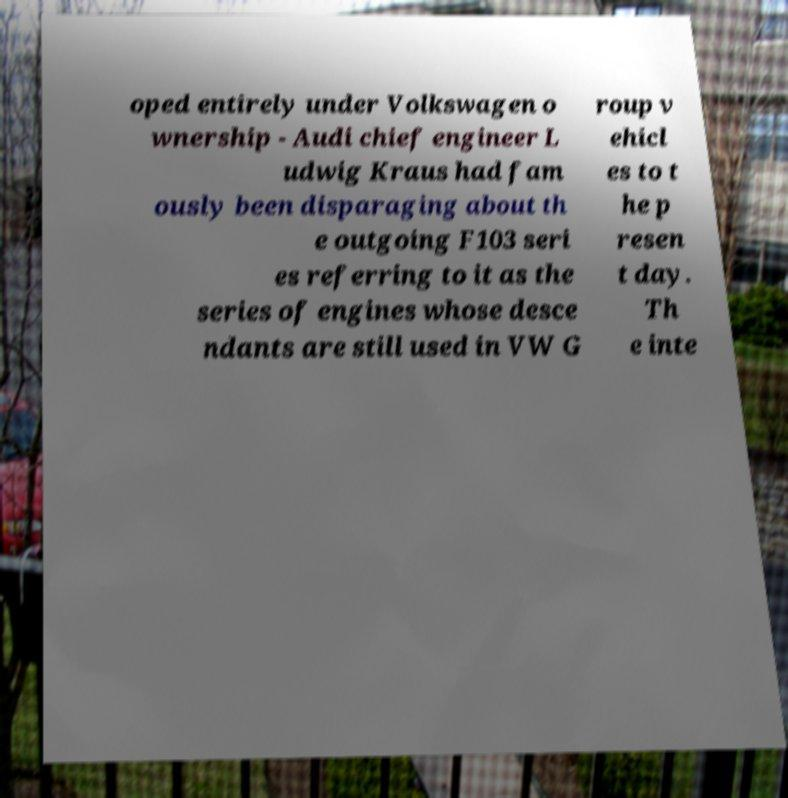Please read and relay the text visible in this image. What does it say? oped entirely under Volkswagen o wnership - Audi chief engineer L udwig Kraus had fam ously been disparaging about th e outgoing F103 seri es referring to it as the series of engines whose desce ndants are still used in VW G roup v ehicl es to t he p resen t day. Th e inte 